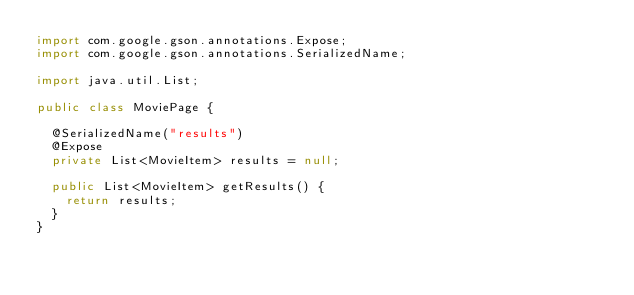<code> <loc_0><loc_0><loc_500><loc_500><_Java_>import com.google.gson.annotations.Expose;
import com.google.gson.annotations.SerializedName;

import java.util.List;

public class MoviePage {

  @SerializedName("results")
  @Expose
  private List<MovieItem> results = null;

  public List<MovieItem> getResults() {
    return results;
  }
}
</code> 